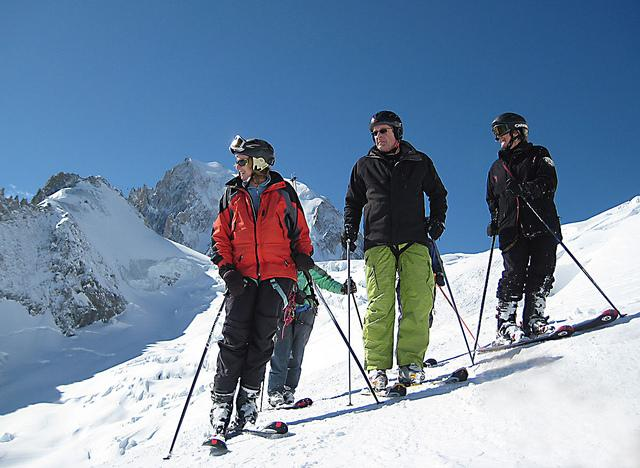What are they ready to do here?

Choices:
A) descend
B) cross
C) ascend
D) retreat descend 